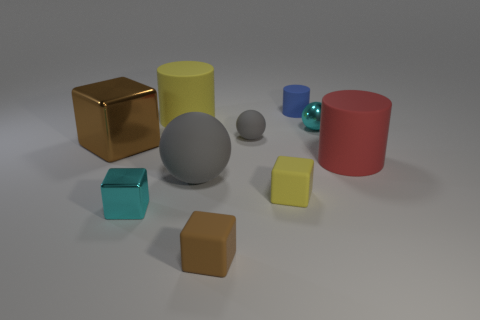Subtract all large cubes. How many cubes are left? 3 Subtract all cyan cylinders. How many gray balls are left? 2 Subtract all cyan cubes. How many cubes are left? 3 Subtract all balls. How many objects are left? 7 Subtract all green spheres. Subtract all gray cubes. How many spheres are left? 3 Add 1 cyan metallic cubes. How many cyan metallic cubes are left? 2 Add 7 small red cylinders. How many small red cylinders exist? 7 Subtract 1 cyan cubes. How many objects are left? 9 Subtract all tiny cubes. Subtract all tiny blue things. How many objects are left? 6 